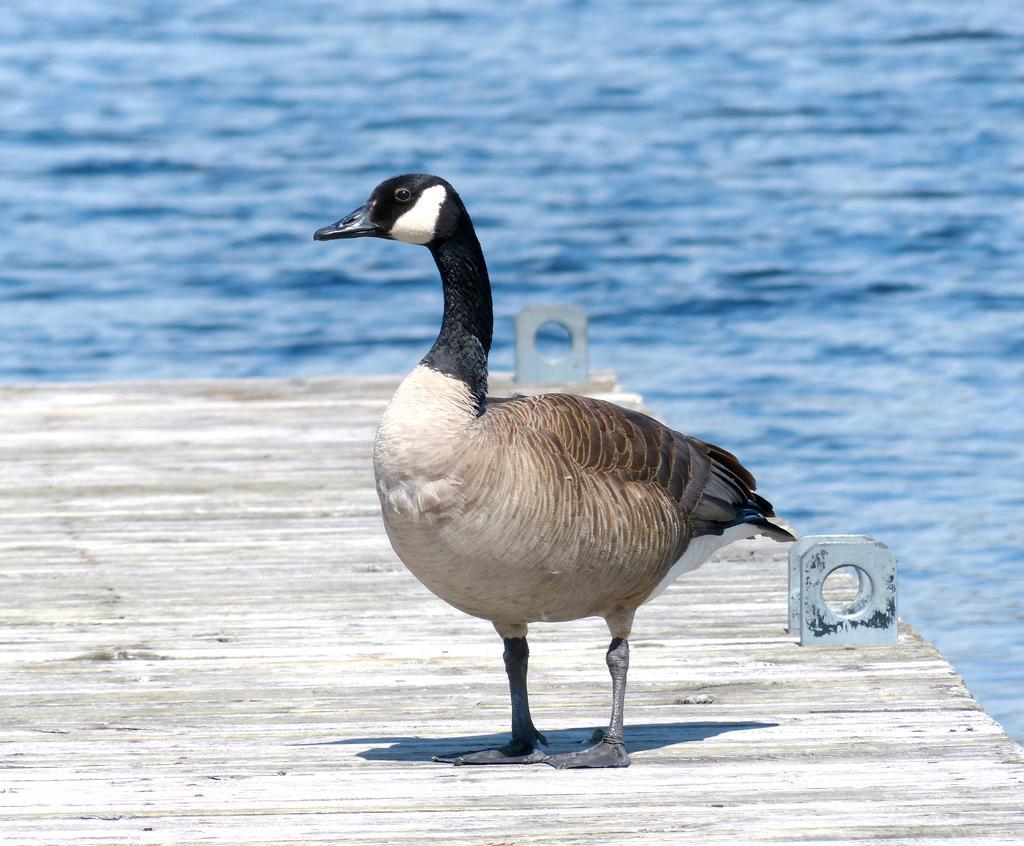Describe this image in one or two sentences. In this image I can see there is a duck standing on a wooden bridge and there is a sea in the background. 